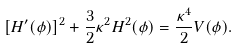<formula> <loc_0><loc_0><loc_500><loc_500>[ H ^ { \prime } ( \phi ) ] ^ { 2 } + \frac { 3 } { 2 } \kappa ^ { 2 } H ^ { 2 } ( \phi ) = \frac { \kappa ^ { 4 } } { 2 } V ( \phi ) .</formula> 